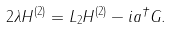Convert formula to latex. <formula><loc_0><loc_0><loc_500><loc_500>2 \lambda H ^ { ( 2 ) } = L _ { 2 } H ^ { ( 2 ) } - i a ^ { \dagger } G .</formula> 